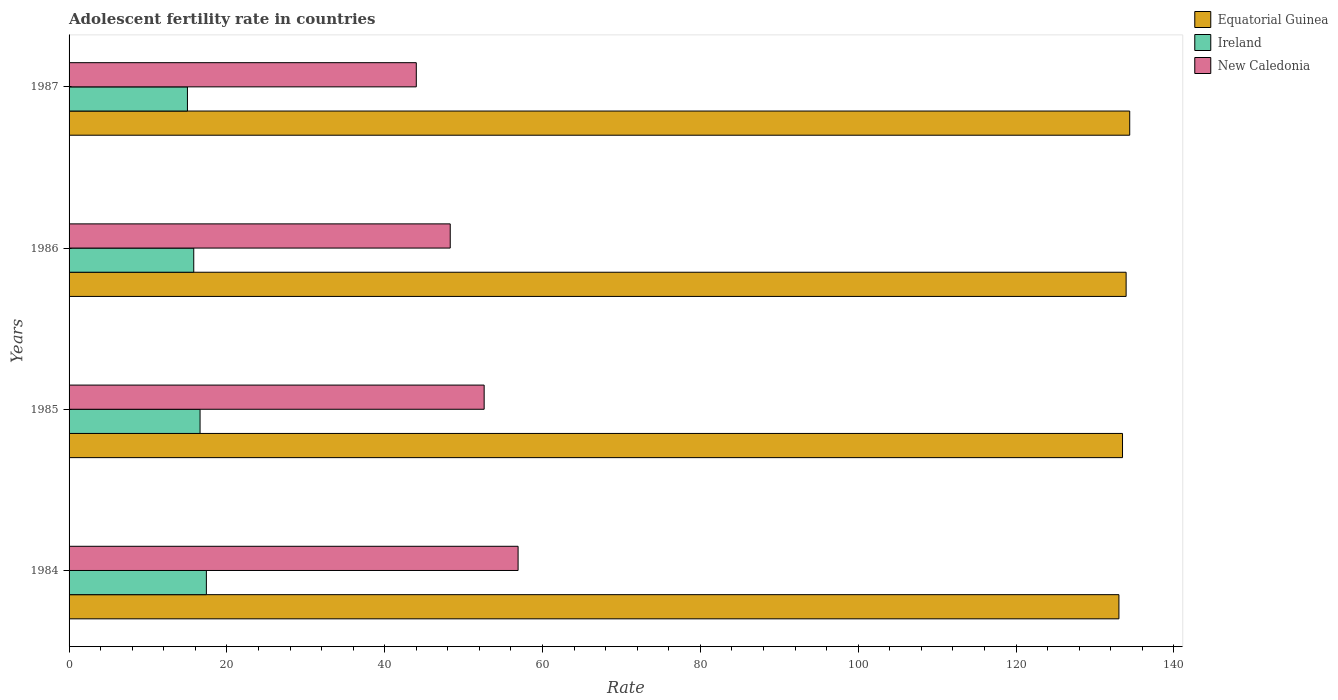Are the number of bars per tick equal to the number of legend labels?
Your answer should be very brief. Yes. Are the number of bars on each tick of the Y-axis equal?
Your answer should be very brief. Yes. How many bars are there on the 4th tick from the bottom?
Make the answer very short. 3. What is the label of the 3rd group of bars from the top?
Provide a short and direct response. 1985. In how many cases, is the number of bars for a given year not equal to the number of legend labels?
Ensure brevity in your answer.  0. What is the adolescent fertility rate in Equatorial Guinea in 1984?
Ensure brevity in your answer.  133.04. Across all years, what is the maximum adolescent fertility rate in Equatorial Guinea?
Make the answer very short. 134.41. Across all years, what is the minimum adolescent fertility rate in Ireland?
Give a very brief answer. 15. In which year was the adolescent fertility rate in New Caledonia maximum?
Offer a terse response. 1984. In which year was the adolescent fertility rate in New Caledonia minimum?
Ensure brevity in your answer.  1987. What is the total adolescent fertility rate in Equatorial Guinea in the graph?
Keep it short and to the point. 534.9. What is the difference between the adolescent fertility rate in Equatorial Guinea in 1984 and that in 1986?
Keep it short and to the point. -0.91. What is the difference between the adolescent fertility rate in Equatorial Guinea in 1986 and the adolescent fertility rate in New Caledonia in 1984?
Keep it short and to the point. 77.05. What is the average adolescent fertility rate in Equatorial Guinea per year?
Offer a terse response. 133.73. In the year 1986, what is the difference between the adolescent fertility rate in New Caledonia and adolescent fertility rate in Equatorial Guinea?
Offer a terse response. -85.65. What is the ratio of the adolescent fertility rate in Ireland in 1984 to that in 1985?
Keep it short and to the point. 1.05. Is the difference between the adolescent fertility rate in New Caledonia in 1985 and 1986 greater than the difference between the adolescent fertility rate in Equatorial Guinea in 1985 and 1986?
Give a very brief answer. Yes. What is the difference between the highest and the second highest adolescent fertility rate in Equatorial Guinea?
Provide a short and direct response. 0.46. What is the difference between the highest and the lowest adolescent fertility rate in Ireland?
Give a very brief answer. 2.4. Is the sum of the adolescent fertility rate in New Caledonia in 1985 and 1987 greater than the maximum adolescent fertility rate in Ireland across all years?
Provide a short and direct response. Yes. What does the 2nd bar from the top in 1986 represents?
Give a very brief answer. Ireland. What does the 3rd bar from the bottom in 1987 represents?
Your answer should be very brief. New Caledonia. Are all the bars in the graph horizontal?
Provide a short and direct response. Yes. How many years are there in the graph?
Keep it short and to the point. 4. What is the difference between two consecutive major ticks on the X-axis?
Offer a very short reply. 20. Are the values on the major ticks of X-axis written in scientific E-notation?
Make the answer very short. No. Where does the legend appear in the graph?
Provide a succinct answer. Top right. What is the title of the graph?
Provide a short and direct response. Adolescent fertility rate in countries. Does "Turks and Caicos Islands" appear as one of the legend labels in the graph?
Keep it short and to the point. No. What is the label or title of the X-axis?
Give a very brief answer. Rate. What is the Rate of Equatorial Guinea in 1984?
Offer a terse response. 133.04. What is the Rate of Ireland in 1984?
Provide a succinct answer. 17.4. What is the Rate in New Caledonia in 1984?
Your answer should be very brief. 56.9. What is the Rate in Equatorial Guinea in 1985?
Give a very brief answer. 133.5. What is the Rate in Ireland in 1985?
Offer a terse response. 16.6. What is the Rate of New Caledonia in 1985?
Give a very brief answer. 52.6. What is the Rate in Equatorial Guinea in 1986?
Make the answer very short. 133.95. What is the Rate of Ireland in 1986?
Keep it short and to the point. 15.8. What is the Rate of New Caledonia in 1986?
Give a very brief answer. 48.3. What is the Rate of Equatorial Guinea in 1987?
Your response must be concise. 134.41. What is the Rate in Ireland in 1987?
Make the answer very short. 15. What is the Rate in New Caledonia in 1987?
Offer a terse response. 44. Across all years, what is the maximum Rate in Equatorial Guinea?
Your response must be concise. 134.41. Across all years, what is the maximum Rate of Ireland?
Your response must be concise. 17.4. Across all years, what is the maximum Rate in New Caledonia?
Give a very brief answer. 56.9. Across all years, what is the minimum Rate of Equatorial Guinea?
Keep it short and to the point. 133.04. Across all years, what is the minimum Rate in Ireland?
Provide a short and direct response. 15. Across all years, what is the minimum Rate in New Caledonia?
Your answer should be very brief. 44. What is the total Rate of Equatorial Guinea in the graph?
Keep it short and to the point. 534.9. What is the total Rate of Ireland in the graph?
Make the answer very short. 64.8. What is the total Rate of New Caledonia in the graph?
Offer a very short reply. 201.81. What is the difference between the Rate of Equatorial Guinea in 1984 and that in 1985?
Your response must be concise. -0.46. What is the difference between the Rate in Equatorial Guinea in 1984 and that in 1986?
Give a very brief answer. -0.91. What is the difference between the Rate of New Caledonia in 1984 and that in 1986?
Provide a succinct answer. 8.6. What is the difference between the Rate in Equatorial Guinea in 1984 and that in 1987?
Provide a succinct answer. -1.37. What is the difference between the Rate of Equatorial Guinea in 1985 and that in 1986?
Ensure brevity in your answer.  -0.46. What is the difference between the Rate of New Caledonia in 1985 and that in 1986?
Offer a very short reply. 4.3. What is the difference between the Rate in Equatorial Guinea in 1985 and that in 1987?
Offer a terse response. -0.91. What is the difference between the Rate of Ireland in 1985 and that in 1987?
Ensure brevity in your answer.  1.6. What is the difference between the Rate in Equatorial Guinea in 1986 and that in 1987?
Your response must be concise. -0.46. What is the difference between the Rate of Ireland in 1986 and that in 1987?
Give a very brief answer. 0.8. What is the difference between the Rate of Equatorial Guinea in 1984 and the Rate of Ireland in 1985?
Give a very brief answer. 116.44. What is the difference between the Rate of Equatorial Guinea in 1984 and the Rate of New Caledonia in 1985?
Make the answer very short. 80.44. What is the difference between the Rate of Ireland in 1984 and the Rate of New Caledonia in 1985?
Give a very brief answer. -35.2. What is the difference between the Rate in Equatorial Guinea in 1984 and the Rate in Ireland in 1986?
Your response must be concise. 117.24. What is the difference between the Rate of Equatorial Guinea in 1984 and the Rate of New Caledonia in 1986?
Ensure brevity in your answer.  84.74. What is the difference between the Rate in Ireland in 1984 and the Rate in New Caledonia in 1986?
Your answer should be compact. -30.9. What is the difference between the Rate of Equatorial Guinea in 1984 and the Rate of Ireland in 1987?
Offer a terse response. 118.04. What is the difference between the Rate of Equatorial Guinea in 1984 and the Rate of New Caledonia in 1987?
Keep it short and to the point. 89.04. What is the difference between the Rate of Ireland in 1984 and the Rate of New Caledonia in 1987?
Ensure brevity in your answer.  -26.6. What is the difference between the Rate in Equatorial Guinea in 1985 and the Rate in Ireland in 1986?
Make the answer very short. 117.7. What is the difference between the Rate of Equatorial Guinea in 1985 and the Rate of New Caledonia in 1986?
Ensure brevity in your answer.  85.2. What is the difference between the Rate of Ireland in 1985 and the Rate of New Caledonia in 1986?
Your answer should be compact. -31.7. What is the difference between the Rate of Equatorial Guinea in 1985 and the Rate of Ireland in 1987?
Ensure brevity in your answer.  118.5. What is the difference between the Rate of Equatorial Guinea in 1985 and the Rate of New Caledonia in 1987?
Give a very brief answer. 89.5. What is the difference between the Rate of Ireland in 1985 and the Rate of New Caledonia in 1987?
Your answer should be very brief. -27.4. What is the difference between the Rate in Equatorial Guinea in 1986 and the Rate in Ireland in 1987?
Provide a short and direct response. 118.95. What is the difference between the Rate in Equatorial Guinea in 1986 and the Rate in New Caledonia in 1987?
Provide a short and direct response. 89.95. What is the difference between the Rate of Ireland in 1986 and the Rate of New Caledonia in 1987?
Offer a very short reply. -28.2. What is the average Rate of Equatorial Guinea per year?
Offer a terse response. 133.73. What is the average Rate of Ireland per year?
Ensure brevity in your answer.  16.2. What is the average Rate of New Caledonia per year?
Your answer should be compact. 50.45. In the year 1984, what is the difference between the Rate of Equatorial Guinea and Rate of Ireland?
Offer a very short reply. 115.64. In the year 1984, what is the difference between the Rate of Equatorial Guinea and Rate of New Caledonia?
Your answer should be compact. 76.14. In the year 1984, what is the difference between the Rate in Ireland and Rate in New Caledonia?
Your response must be concise. -39.5. In the year 1985, what is the difference between the Rate in Equatorial Guinea and Rate in Ireland?
Your answer should be very brief. 116.9. In the year 1985, what is the difference between the Rate in Equatorial Guinea and Rate in New Caledonia?
Make the answer very short. 80.9. In the year 1985, what is the difference between the Rate in Ireland and Rate in New Caledonia?
Provide a short and direct response. -36. In the year 1986, what is the difference between the Rate of Equatorial Guinea and Rate of Ireland?
Your answer should be very brief. 118.15. In the year 1986, what is the difference between the Rate of Equatorial Guinea and Rate of New Caledonia?
Provide a short and direct response. 85.65. In the year 1986, what is the difference between the Rate in Ireland and Rate in New Caledonia?
Offer a very short reply. -32.5. In the year 1987, what is the difference between the Rate of Equatorial Guinea and Rate of Ireland?
Give a very brief answer. 119.41. In the year 1987, what is the difference between the Rate in Equatorial Guinea and Rate in New Caledonia?
Provide a short and direct response. 90.41. In the year 1987, what is the difference between the Rate of Ireland and Rate of New Caledonia?
Give a very brief answer. -29. What is the ratio of the Rate of Equatorial Guinea in 1984 to that in 1985?
Provide a succinct answer. 1. What is the ratio of the Rate in Ireland in 1984 to that in 1985?
Provide a short and direct response. 1.05. What is the ratio of the Rate of New Caledonia in 1984 to that in 1985?
Your answer should be compact. 1.08. What is the ratio of the Rate in Equatorial Guinea in 1984 to that in 1986?
Ensure brevity in your answer.  0.99. What is the ratio of the Rate in Ireland in 1984 to that in 1986?
Keep it short and to the point. 1.1. What is the ratio of the Rate in New Caledonia in 1984 to that in 1986?
Your answer should be very brief. 1.18. What is the ratio of the Rate in Equatorial Guinea in 1984 to that in 1987?
Your answer should be compact. 0.99. What is the ratio of the Rate in Ireland in 1984 to that in 1987?
Keep it short and to the point. 1.16. What is the ratio of the Rate of New Caledonia in 1984 to that in 1987?
Your answer should be compact. 1.29. What is the ratio of the Rate of Equatorial Guinea in 1985 to that in 1986?
Provide a short and direct response. 1. What is the ratio of the Rate of Ireland in 1985 to that in 1986?
Ensure brevity in your answer.  1.05. What is the ratio of the Rate in New Caledonia in 1985 to that in 1986?
Offer a very short reply. 1.09. What is the ratio of the Rate of Equatorial Guinea in 1985 to that in 1987?
Provide a succinct answer. 0.99. What is the ratio of the Rate of Ireland in 1985 to that in 1987?
Your answer should be compact. 1.11. What is the ratio of the Rate of New Caledonia in 1985 to that in 1987?
Your answer should be very brief. 1.2. What is the ratio of the Rate in Ireland in 1986 to that in 1987?
Provide a short and direct response. 1.05. What is the ratio of the Rate in New Caledonia in 1986 to that in 1987?
Offer a very short reply. 1.1. What is the difference between the highest and the second highest Rate in Equatorial Guinea?
Offer a very short reply. 0.46. What is the difference between the highest and the second highest Rate of New Caledonia?
Offer a very short reply. 4.3. What is the difference between the highest and the lowest Rate of Equatorial Guinea?
Ensure brevity in your answer.  1.37. What is the difference between the highest and the lowest Rate in Ireland?
Provide a succinct answer. 2.4. 